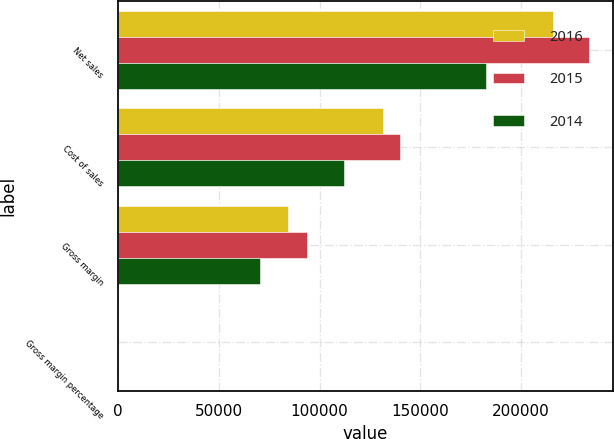Convert chart to OTSL. <chart><loc_0><loc_0><loc_500><loc_500><stacked_bar_chart><ecel><fcel>Net sales<fcel>Cost of sales<fcel>Gross margin<fcel>Gross margin percentage<nl><fcel>2016<fcel>215639<fcel>131376<fcel>84263<fcel>39.1<nl><fcel>2015<fcel>233715<fcel>140089<fcel>93626<fcel>40.1<nl><fcel>2014<fcel>182795<fcel>112258<fcel>70537<fcel>38.6<nl></chart> 